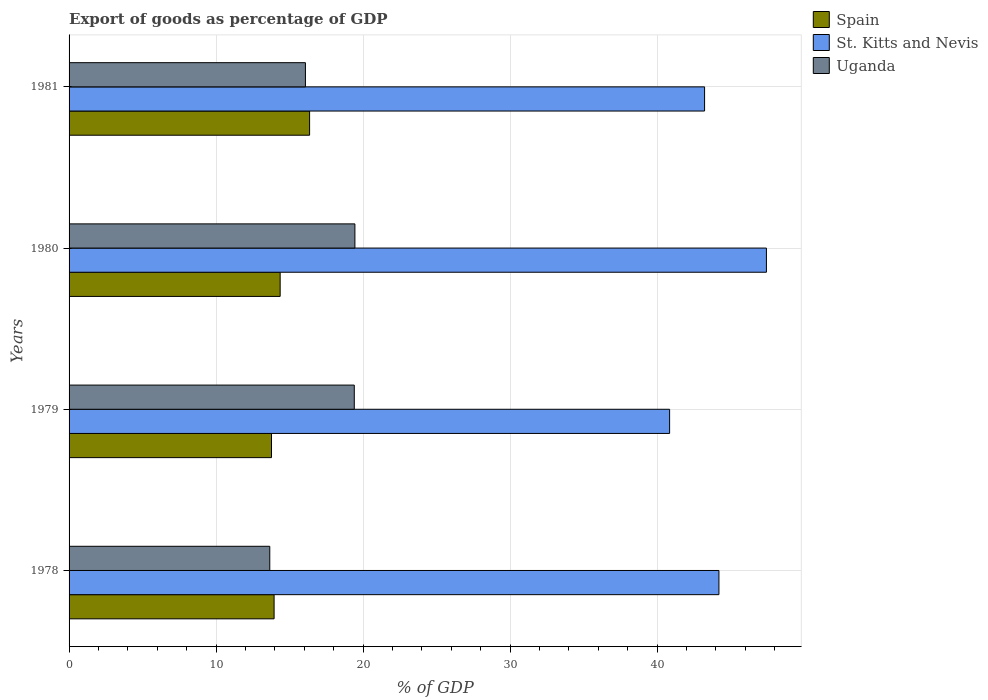How many different coloured bars are there?
Your answer should be very brief. 3. How many bars are there on the 3rd tick from the bottom?
Your answer should be compact. 3. What is the label of the 1st group of bars from the top?
Provide a succinct answer. 1981. What is the export of goods as percentage of GDP in St. Kitts and Nevis in 1980?
Offer a terse response. 47.44. Across all years, what is the maximum export of goods as percentage of GDP in Spain?
Offer a terse response. 16.36. Across all years, what is the minimum export of goods as percentage of GDP in Uganda?
Provide a succinct answer. 13.65. In which year was the export of goods as percentage of GDP in Spain maximum?
Provide a succinct answer. 1981. In which year was the export of goods as percentage of GDP in Spain minimum?
Offer a very short reply. 1979. What is the total export of goods as percentage of GDP in St. Kitts and Nevis in the graph?
Your response must be concise. 175.73. What is the difference between the export of goods as percentage of GDP in Spain in 1979 and that in 1980?
Your response must be concise. -0.59. What is the difference between the export of goods as percentage of GDP in St. Kitts and Nevis in 1980 and the export of goods as percentage of GDP in Uganda in 1979?
Provide a short and direct response. 28.04. What is the average export of goods as percentage of GDP in Uganda per year?
Offer a very short reply. 17.14. In the year 1978, what is the difference between the export of goods as percentage of GDP in Uganda and export of goods as percentage of GDP in St. Kitts and Nevis?
Offer a terse response. -30.55. What is the ratio of the export of goods as percentage of GDP in Uganda in 1980 to that in 1981?
Your response must be concise. 1.21. What is the difference between the highest and the second highest export of goods as percentage of GDP in St. Kitts and Nevis?
Your answer should be compact. 3.23. What is the difference between the highest and the lowest export of goods as percentage of GDP in St. Kitts and Nevis?
Your response must be concise. 6.59. What does the 2nd bar from the top in 1981 represents?
Your answer should be compact. St. Kitts and Nevis. What does the 2nd bar from the bottom in 1978 represents?
Your response must be concise. St. Kitts and Nevis. Is it the case that in every year, the sum of the export of goods as percentage of GDP in Spain and export of goods as percentage of GDP in Uganda is greater than the export of goods as percentage of GDP in St. Kitts and Nevis?
Ensure brevity in your answer.  No. How many bars are there?
Ensure brevity in your answer.  12. Are all the bars in the graph horizontal?
Keep it short and to the point. Yes. Where does the legend appear in the graph?
Give a very brief answer. Top right. How are the legend labels stacked?
Your answer should be compact. Vertical. What is the title of the graph?
Offer a terse response. Export of goods as percentage of GDP. Does "Albania" appear as one of the legend labels in the graph?
Offer a terse response. No. What is the label or title of the X-axis?
Provide a succinct answer. % of GDP. What is the label or title of the Y-axis?
Your response must be concise. Years. What is the % of GDP in Spain in 1978?
Ensure brevity in your answer.  13.95. What is the % of GDP in St. Kitts and Nevis in 1978?
Make the answer very short. 44.21. What is the % of GDP of Uganda in 1978?
Give a very brief answer. 13.65. What is the % of GDP in Spain in 1979?
Your answer should be compact. 13.77. What is the % of GDP in St. Kitts and Nevis in 1979?
Provide a succinct answer. 40.85. What is the % of GDP of Uganda in 1979?
Make the answer very short. 19.4. What is the % of GDP of Spain in 1980?
Your answer should be very brief. 14.36. What is the % of GDP in St. Kitts and Nevis in 1980?
Your response must be concise. 47.44. What is the % of GDP of Uganda in 1980?
Your answer should be compact. 19.44. What is the % of GDP of Spain in 1981?
Your response must be concise. 16.36. What is the % of GDP in St. Kitts and Nevis in 1981?
Keep it short and to the point. 43.23. What is the % of GDP in Uganda in 1981?
Make the answer very short. 16.08. Across all years, what is the maximum % of GDP in Spain?
Provide a succinct answer. 16.36. Across all years, what is the maximum % of GDP of St. Kitts and Nevis?
Provide a succinct answer. 47.44. Across all years, what is the maximum % of GDP of Uganda?
Provide a short and direct response. 19.44. Across all years, what is the minimum % of GDP of Spain?
Your response must be concise. 13.77. Across all years, what is the minimum % of GDP in St. Kitts and Nevis?
Ensure brevity in your answer.  40.85. Across all years, what is the minimum % of GDP of Uganda?
Your response must be concise. 13.65. What is the total % of GDP in Spain in the graph?
Provide a succinct answer. 58.44. What is the total % of GDP of St. Kitts and Nevis in the graph?
Your answer should be compact. 175.73. What is the total % of GDP of Uganda in the graph?
Give a very brief answer. 68.58. What is the difference between the % of GDP in Spain in 1978 and that in 1979?
Your response must be concise. 0.18. What is the difference between the % of GDP in St. Kitts and Nevis in 1978 and that in 1979?
Offer a very short reply. 3.36. What is the difference between the % of GDP in Uganda in 1978 and that in 1979?
Give a very brief answer. -5.75. What is the difference between the % of GDP in Spain in 1978 and that in 1980?
Provide a succinct answer. -0.41. What is the difference between the % of GDP of St. Kitts and Nevis in 1978 and that in 1980?
Make the answer very short. -3.23. What is the difference between the % of GDP of Uganda in 1978 and that in 1980?
Provide a short and direct response. -5.79. What is the difference between the % of GDP of Spain in 1978 and that in 1981?
Provide a short and direct response. -2.42. What is the difference between the % of GDP in St. Kitts and Nevis in 1978 and that in 1981?
Offer a very short reply. 0.98. What is the difference between the % of GDP of Uganda in 1978 and that in 1981?
Your response must be concise. -2.42. What is the difference between the % of GDP in Spain in 1979 and that in 1980?
Keep it short and to the point. -0.59. What is the difference between the % of GDP in St. Kitts and Nevis in 1979 and that in 1980?
Offer a very short reply. -6.59. What is the difference between the % of GDP of Uganda in 1979 and that in 1980?
Offer a very short reply. -0.04. What is the difference between the % of GDP of Spain in 1979 and that in 1981?
Your response must be concise. -2.59. What is the difference between the % of GDP of St. Kitts and Nevis in 1979 and that in 1981?
Offer a very short reply. -2.38. What is the difference between the % of GDP in Uganda in 1979 and that in 1981?
Offer a terse response. 3.32. What is the difference between the % of GDP of Spain in 1980 and that in 1981?
Keep it short and to the point. -2. What is the difference between the % of GDP of St. Kitts and Nevis in 1980 and that in 1981?
Provide a short and direct response. 4.21. What is the difference between the % of GDP in Uganda in 1980 and that in 1981?
Your response must be concise. 3.37. What is the difference between the % of GDP of Spain in 1978 and the % of GDP of St. Kitts and Nevis in 1979?
Your answer should be compact. -26.9. What is the difference between the % of GDP in Spain in 1978 and the % of GDP in Uganda in 1979?
Provide a short and direct response. -5.46. What is the difference between the % of GDP of St. Kitts and Nevis in 1978 and the % of GDP of Uganda in 1979?
Your answer should be compact. 24.81. What is the difference between the % of GDP in Spain in 1978 and the % of GDP in St. Kitts and Nevis in 1980?
Provide a short and direct response. -33.49. What is the difference between the % of GDP in Spain in 1978 and the % of GDP in Uganda in 1980?
Give a very brief answer. -5.5. What is the difference between the % of GDP of St. Kitts and Nevis in 1978 and the % of GDP of Uganda in 1980?
Your response must be concise. 24.76. What is the difference between the % of GDP in Spain in 1978 and the % of GDP in St. Kitts and Nevis in 1981?
Give a very brief answer. -29.28. What is the difference between the % of GDP of Spain in 1978 and the % of GDP of Uganda in 1981?
Ensure brevity in your answer.  -2.13. What is the difference between the % of GDP of St. Kitts and Nevis in 1978 and the % of GDP of Uganda in 1981?
Make the answer very short. 28.13. What is the difference between the % of GDP of Spain in 1979 and the % of GDP of St. Kitts and Nevis in 1980?
Your response must be concise. -33.67. What is the difference between the % of GDP of Spain in 1979 and the % of GDP of Uganda in 1980?
Provide a short and direct response. -5.67. What is the difference between the % of GDP in St. Kitts and Nevis in 1979 and the % of GDP in Uganda in 1980?
Your answer should be very brief. 21.41. What is the difference between the % of GDP of Spain in 1979 and the % of GDP of St. Kitts and Nevis in 1981?
Your answer should be compact. -29.46. What is the difference between the % of GDP of Spain in 1979 and the % of GDP of Uganda in 1981?
Provide a short and direct response. -2.31. What is the difference between the % of GDP in St. Kitts and Nevis in 1979 and the % of GDP in Uganda in 1981?
Provide a short and direct response. 24.77. What is the difference between the % of GDP of Spain in 1980 and the % of GDP of St. Kitts and Nevis in 1981?
Provide a succinct answer. -28.87. What is the difference between the % of GDP in Spain in 1980 and the % of GDP in Uganda in 1981?
Provide a succinct answer. -1.72. What is the difference between the % of GDP in St. Kitts and Nevis in 1980 and the % of GDP in Uganda in 1981?
Provide a short and direct response. 31.36. What is the average % of GDP in Spain per year?
Offer a very short reply. 14.61. What is the average % of GDP of St. Kitts and Nevis per year?
Offer a terse response. 43.93. What is the average % of GDP in Uganda per year?
Provide a short and direct response. 17.14. In the year 1978, what is the difference between the % of GDP of Spain and % of GDP of St. Kitts and Nevis?
Keep it short and to the point. -30.26. In the year 1978, what is the difference between the % of GDP of Spain and % of GDP of Uganda?
Give a very brief answer. 0.29. In the year 1978, what is the difference between the % of GDP in St. Kitts and Nevis and % of GDP in Uganda?
Give a very brief answer. 30.55. In the year 1979, what is the difference between the % of GDP in Spain and % of GDP in St. Kitts and Nevis?
Provide a short and direct response. -27.08. In the year 1979, what is the difference between the % of GDP in Spain and % of GDP in Uganda?
Ensure brevity in your answer.  -5.63. In the year 1979, what is the difference between the % of GDP of St. Kitts and Nevis and % of GDP of Uganda?
Offer a terse response. 21.45. In the year 1980, what is the difference between the % of GDP of Spain and % of GDP of St. Kitts and Nevis?
Offer a terse response. -33.08. In the year 1980, what is the difference between the % of GDP in Spain and % of GDP in Uganda?
Give a very brief answer. -5.08. In the year 1980, what is the difference between the % of GDP of St. Kitts and Nevis and % of GDP of Uganda?
Ensure brevity in your answer.  27.99. In the year 1981, what is the difference between the % of GDP of Spain and % of GDP of St. Kitts and Nevis?
Keep it short and to the point. -26.87. In the year 1981, what is the difference between the % of GDP in Spain and % of GDP in Uganda?
Offer a terse response. 0.28. In the year 1981, what is the difference between the % of GDP in St. Kitts and Nevis and % of GDP in Uganda?
Make the answer very short. 27.15. What is the ratio of the % of GDP of Spain in 1978 to that in 1979?
Give a very brief answer. 1.01. What is the ratio of the % of GDP of St. Kitts and Nevis in 1978 to that in 1979?
Make the answer very short. 1.08. What is the ratio of the % of GDP of Uganda in 1978 to that in 1979?
Your response must be concise. 0.7. What is the ratio of the % of GDP in Spain in 1978 to that in 1980?
Ensure brevity in your answer.  0.97. What is the ratio of the % of GDP in St. Kitts and Nevis in 1978 to that in 1980?
Your answer should be compact. 0.93. What is the ratio of the % of GDP in Uganda in 1978 to that in 1980?
Offer a terse response. 0.7. What is the ratio of the % of GDP of Spain in 1978 to that in 1981?
Provide a succinct answer. 0.85. What is the ratio of the % of GDP of St. Kitts and Nevis in 1978 to that in 1981?
Make the answer very short. 1.02. What is the ratio of the % of GDP of Uganda in 1978 to that in 1981?
Offer a very short reply. 0.85. What is the ratio of the % of GDP in Spain in 1979 to that in 1980?
Provide a short and direct response. 0.96. What is the ratio of the % of GDP of St. Kitts and Nevis in 1979 to that in 1980?
Provide a short and direct response. 0.86. What is the ratio of the % of GDP of Spain in 1979 to that in 1981?
Make the answer very short. 0.84. What is the ratio of the % of GDP in St. Kitts and Nevis in 1979 to that in 1981?
Offer a very short reply. 0.94. What is the ratio of the % of GDP in Uganda in 1979 to that in 1981?
Provide a short and direct response. 1.21. What is the ratio of the % of GDP in Spain in 1980 to that in 1981?
Your response must be concise. 0.88. What is the ratio of the % of GDP in St. Kitts and Nevis in 1980 to that in 1981?
Your answer should be very brief. 1.1. What is the ratio of the % of GDP of Uganda in 1980 to that in 1981?
Provide a succinct answer. 1.21. What is the difference between the highest and the second highest % of GDP in Spain?
Provide a succinct answer. 2. What is the difference between the highest and the second highest % of GDP in St. Kitts and Nevis?
Give a very brief answer. 3.23. What is the difference between the highest and the second highest % of GDP in Uganda?
Give a very brief answer. 0.04. What is the difference between the highest and the lowest % of GDP of Spain?
Your answer should be compact. 2.59. What is the difference between the highest and the lowest % of GDP in St. Kitts and Nevis?
Provide a short and direct response. 6.59. What is the difference between the highest and the lowest % of GDP of Uganda?
Make the answer very short. 5.79. 